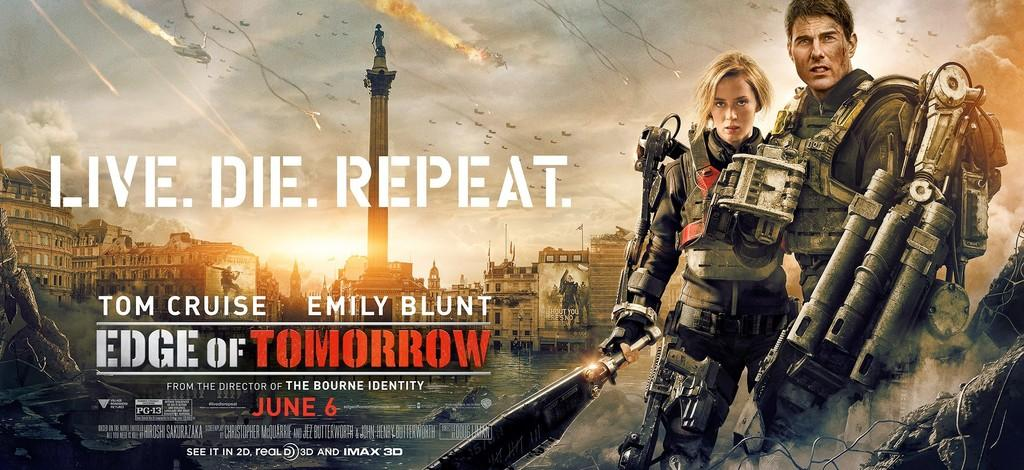<image>
Relay a brief, clear account of the picture shown. a movie poster that has The Edge of Tomorrow written on it 